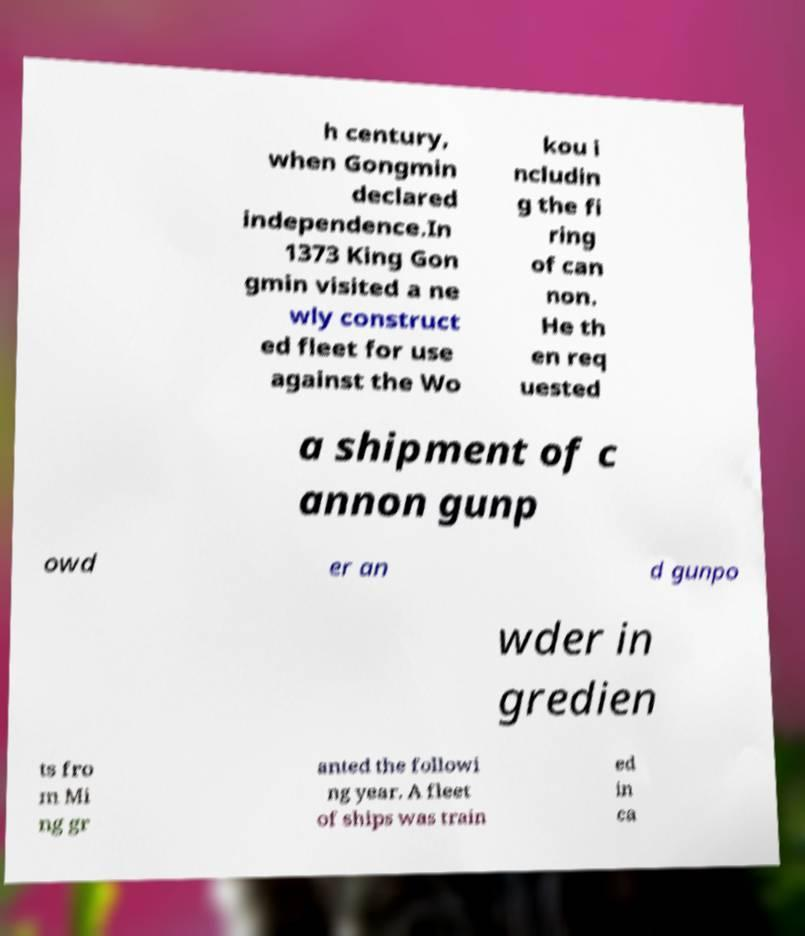Please read and relay the text visible in this image. What does it say? h century, when Gongmin declared independence.In 1373 King Gon gmin visited a ne wly construct ed fleet for use against the Wo kou i ncludin g the fi ring of can non. He th en req uested a shipment of c annon gunp owd er an d gunpo wder in gredien ts fro m Mi ng gr anted the followi ng year. A fleet of ships was train ed in ca 